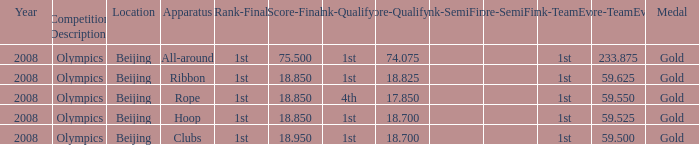What was her final score on the ribbon apparatus? 18.85. 